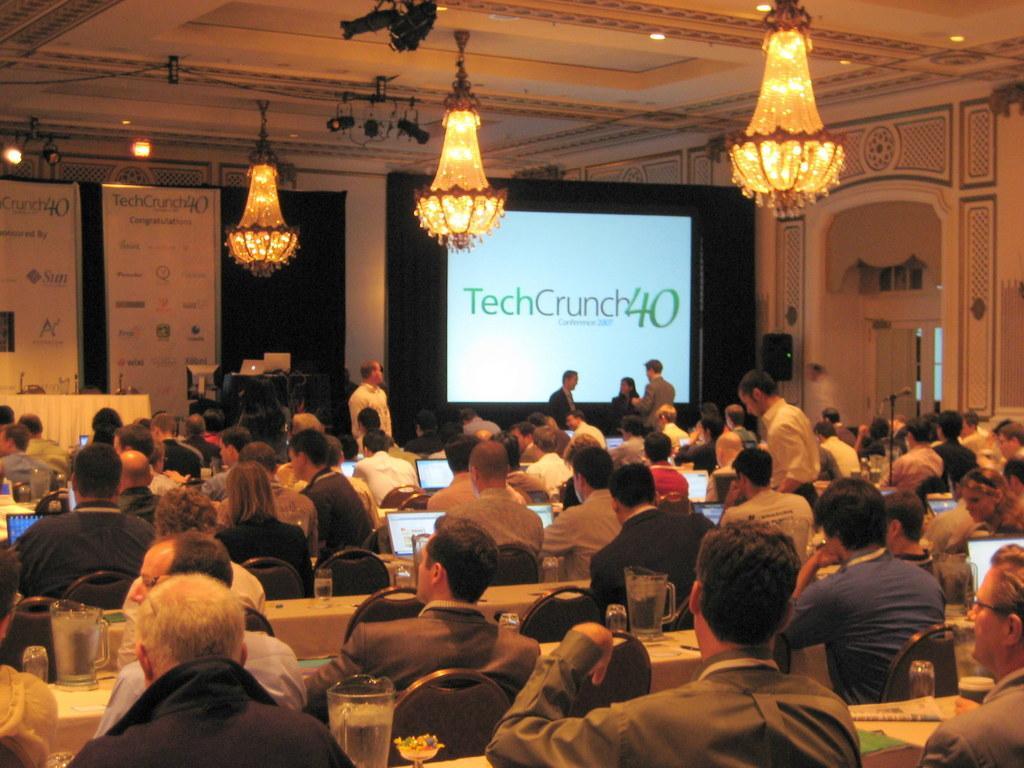Could you give a brief overview of what you see in this image? In this image there are persons sitting and standing and there are tables and on the table there are glasses, jars, there are laptops. In the background there is a screen with some text written on it and there are banners with some text written on it, there are laptops, there is a table which is covered with a white colour cloth and there is an object which is black in colour, there is a mic, there are curtains and at the top there are lights. 